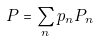Convert formula to latex. <formula><loc_0><loc_0><loc_500><loc_500>P = \sum _ { n } p _ { n } P _ { n }</formula> 